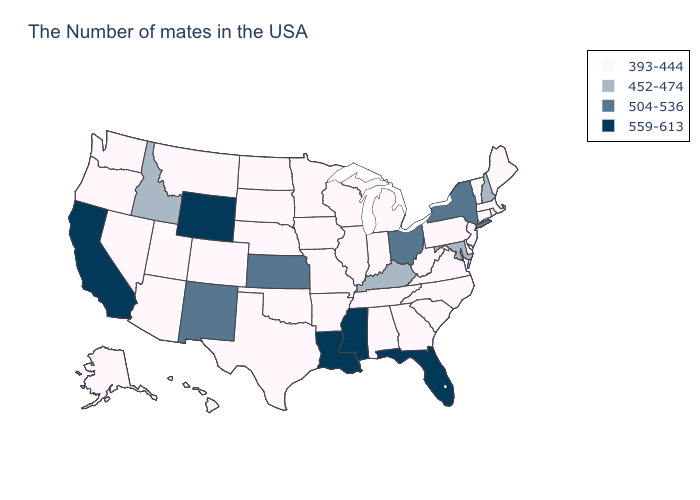Does Rhode Island have the lowest value in the USA?
Write a very short answer. Yes. What is the lowest value in the USA?
Keep it brief. 393-444. What is the lowest value in the MidWest?
Quick response, please. 393-444. What is the highest value in the South ?
Quick response, please. 559-613. What is the highest value in the West ?
Write a very short answer. 559-613. Name the states that have a value in the range 452-474?
Write a very short answer. New Hampshire, Maryland, Kentucky, Idaho. Name the states that have a value in the range 393-444?
Concise answer only. Maine, Massachusetts, Rhode Island, Vermont, Connecticut, New Jersey, Delaware, Pennsylvania, Virginia, North Carolina, South Carolina, West Virginia, Georgia, Michigan, Indiana, Alabama, Tennessee, Wisconsin, Illinois, Missouri, Arkansas, Minnesota, Iowa, Nebraska, Oklahoma, Texas, South Dakota, North Dakota, Colorado, Utah, Montana, Arizona, Nevada, Washington, Oregon, Alaska, Hawaii. Name the states that have a value in the range 504-536?
Keep it brief. New York, Ohio, Kansas, New Mexico. What is the value of Kansas?
Keep it brief. 504-536. Which states have the highest value in the USA?
Give a very brief answer. Florida, Mississippi, Louisiana, Wyoming, California. What is the lowest value in states that border New Mexico?
Concise answer only. 393-444. What is the value of Idaho?
Keep it brief. 452-474. Which states have the lowest value in the MidWest?
Concise answer only. Michigan, Indiana, Wisconsin, Illinois, Missouri, Minnesota, Iowa, Nebraska, South Dakota, North Dakota. What is the value of Georgia?
Answer briefly. 393-444. 